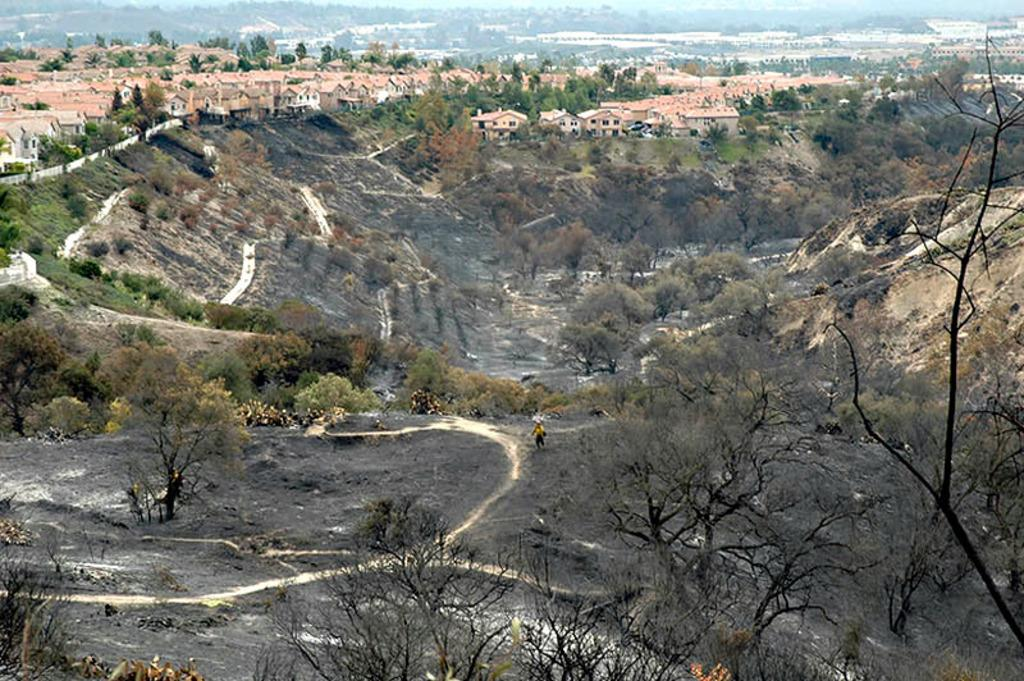What type of structures can be seen in the image? There are buildings in the image. What is located at the bottom of the image? There are trees and roads at the bottom of the image. What can be seen in the background of the image? There are hills and the sky visible in the background of the image. What type of underwear is hanging on the trees in the image? There is no underwear present in the image; it only features buildings, trees, roads, hills, and the sky. 